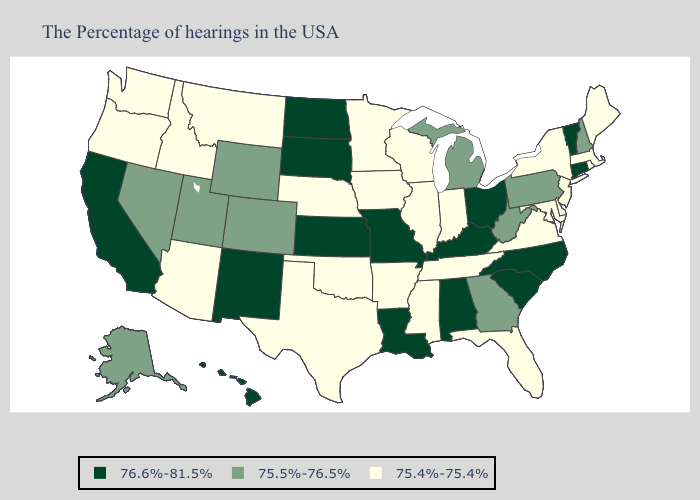What is the value of Minnesota?
Concise answer only. 75.4%-75.4%. What is the value of Washington?
Answer briefly. 75.4%-75.4%. Name the states that have a value in the range 75.5%-76.5%?
Short answer required. New Hampshire, Pennsylvania, West Virginia, Georgia, Michigan, Wyoming, Colorado, Utah, Nevada, Alaska. Name the states that have a value in the range 76.6%-81.5%?
Keep it brief. Vermont, Connecticut, North Carolina, South Carolina, Ohio, Kentucky, Alabama, Louisiana, Missouri, Kansas, South Dakota, North Dakota, New Mexico, California, Hawaii. What is the value of Oregon?
Quick response, please. 75.4%-75.4%. What is the value of Massachusetts?
Be succinct. 75.4%-75.4%. Name the states that have a value in the range 75.5%-76.5%?
Quick response, please. New Hampshire, Pennsylvania, West Virginia, Georgia, Michigan, Wyoming, Colorado, Utah, Nevada, Alaska. Which states have the lowest value in the MidWest?
Answer briefly. Indiana, Wisconsin, Illinois, Minnesota, Iowa, Nebraska. Does Arizona have the lowest value in the West?
Be succinct. Yes. How many symbols are there in the legend?
Concise answer only. 3. Name the states that have a value in the range 75.4%-75.4%?
Give a very brief answer. Maine, Massachusetts, Rhode Island, New York, New Jersey, Delaware, Maryland, Virginia, Florida, Indiana, Tennessee, Wisconsin, Illinois, Mississippi, Arkansas, Minnesota, Iowa, Nebraska, Oklahoma, Texas, Montana, Arizona, Idaho, Washington, Oregon. How many symbols are there in the legend?
Give a very brief answer. 3. Name the states that have a value in the range 76.6%-81.5%?
Concise answer only. Vermont, Connecticut, North Carolina, South Carolina, Ohio, Kentucky, Alabama, Louisiana, Missouri, Kansas, South Dakota, North Dakota, New Mexico, California, Hawaii. Among the states that border Colorado , which have the highest value?
Keep it brief. Kansas, New Mexico. What is the highest value in the USA?
Concise answer only. 76.6%-81.5%. 